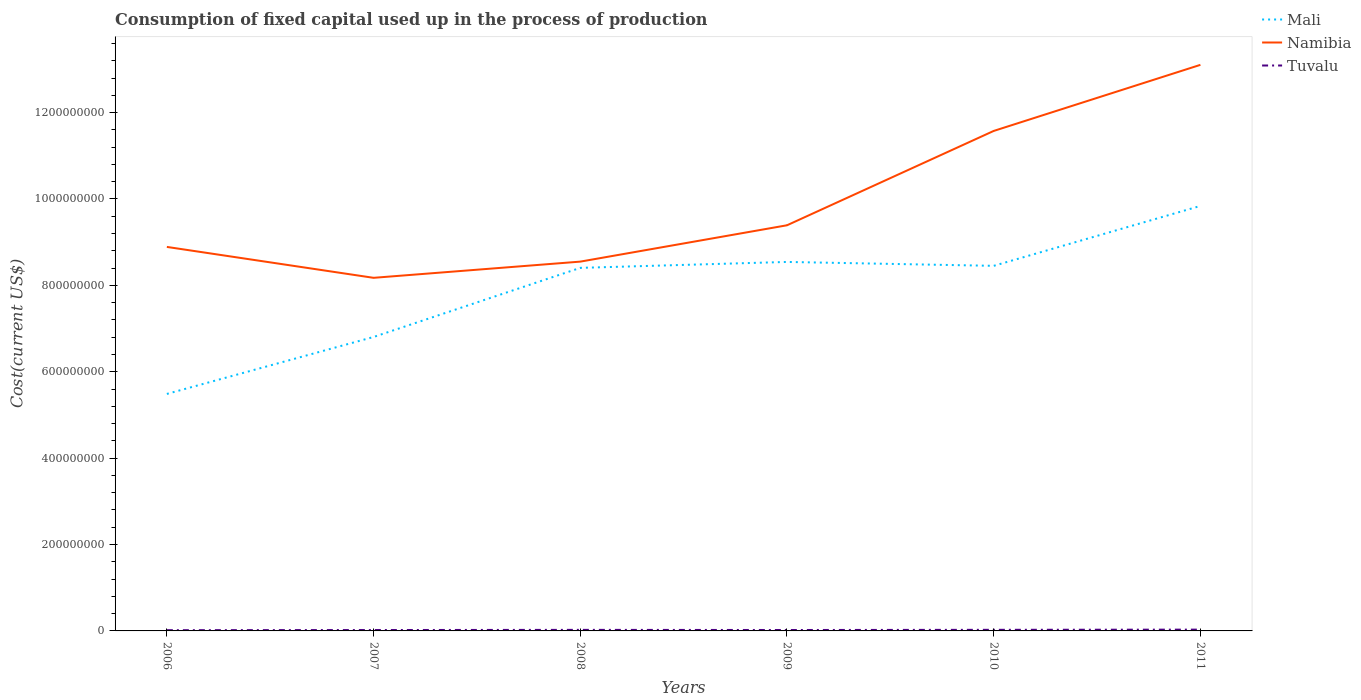Does the line corresponding to Namibia intersect with the line corresponding to Tuvalu?
Offer a very short reply. No. Across all years, what is the maximum amount consumed in the process of production in Tuvalu?
Keep it short and to the point. 1.71e+06. In which year was the amount consumed in the process of production in Mali maximum?
Offer a very short reply. 2006. What is the total amount consumed in the process of production in Namibia in the graph?
Give a very brief answer. -5.01e+07. What is the difference between the highest and the second highest amount consumed in the process of production in Namibia?
Offer a terse response. 4.93e+08. How many years are there in the graph?
Ensure brevity in your answer.  6. What is the difference between two consecutive major ticks on the Y-axis?
Your response must be concise. 2.00e+08. Are the values on the major ticks of Y-axis written in scientific E-notation?
Offer a terse response. No. Does the graph contain grids?
Make the answer very short. No. How are the legend labels stacked?
Offer a terse response. Vertical. What is the title of the graph?
Ensure brevity in your answer.  Consumption of fixed capital used up in the process of production. Does "Lao PDR" appear as one of the legend labels in the graph?
Give a very brief answer. No. What is the label or title of the Y-axis?
Your response must be concise. Cost(current US$). What is the Cost(current US$) in Mali in 2006?
Your answer should be compact. 5.49e+08. What is the Cost(current US$) in Namibia in 2006?
Offer a very short reply. 8.89e+08. What is the Cost(current US$) in Tuvalu in 2006?
Provide a succinct answer. 1.71e+06. What is the Cost(current US$) of Mali in 2007?
Your response must be concise. 6.81e+08. What is the Cost(current US$) of Namibia in 2007?
Give a very brief answer. 8.17e+08. What is the Cost(current US$) of Tuvalu in 2007?
Offer a terse response. 2.07e+06. What is the Cost(current US$) in Mali in 2008?
Your answer should be compact. 8.41e+08. What is the Cost(current US$) of Namibia in 2008?
Provide a succinct answer. 8.55e+08. What is the Cost(current US$) of Tuvalu in 2008?
Give a very brief answer. 2.43e+06. What is the Cost(current US$) in Mali in 2009?
Provide a succinct answer. 8.54e+08. What is the Cost(current US$) in Namibia in 2009?
Make the answer very short. 9.39e+08. What is the Cost(current US$) in Tuvalu in 2009?
Your answer should be very brief. 2.11e+06. What is the Cost(current US$) in Mali in 2010?
Give a very brief answer. 8.45e+08. What is the Cost(current US$) of Namibia in 2010?
Your answer should be very brief. 1.16e+09. What is the Cost(current US$) in Tuvalu in 2010?
Keep it short and to the point. 2.54e+06. What is the Cost(current US$) of Mali in 2011?
Keep it short and to the point. 9.84e+08. What is the Cost(current US$) in Namibia in 2011?
Ensure brevity in your answer.  1.31e+09. What is the Cost(current US$) in Tuvalu in 2011?
Provide a succinct answer. 3.00e+06. Across all years, what is the maximum Cost(current US$) of Mali?
Ensure brevity in your answer.  9.84e+08. Across all years, what is the maximum Cost(current US$) of Namibia?
Give a very brief answer. 1.31e+09. Across all years, what is the maximum Cost(current US$) of Tuvalu?
Provide a succinct answer. 3.00e+06. Across all years, what is the minimum Cost(current US$) in Mali?
Your answer should be compact. 5.49e+08. Across all years, what is the minimum Cost(current US$) of Namibia?
Provide a short and direct response. 8.17e+08. Across all years, what is the minimum Cost(current US$) in Tuvalu?
Ensure brevity in your answer.  1.71e+06. What is the total Cost(current US$) of Mali in the graph?
Keep it short and to the point. 4.75e+09. What is the total Cost(current US$) of Namibia in the graph?
Your answer should be compact. 5.97e+09. What is the total Cost(current US$) in Tuvalu in the graph?
Ensure brevity in your answer.  1.39e+07. What is the difference between the Cost(current US$) of Mali in 2006 and that in 2007?
Keep it short and to the point. -1.32e+08. What is the difference between the Cost(current US$) of Namibia in 2006 and that in 2007?
Provide a short and direct response. 7.16e+07. What is the difference between the Cost(current US$) of Tuvalu in 2006 and that in 2007?
Make the answer very short. -3.62e+05. What is the difference between the Cost(current US$) of Mali in 2006 and that in 2008?
Your answer should be very brief. -2.92e+08. What is the difference between the Cost(current US$) in Namibia in 2006 and that in 2008?
Your answer should be very brief. 3.40e+07. What is the difference between the Cost(current US$) of Tuvalu in 2006 and that in 2008?
Your response must be concise. -7.25e+05. What is the difference between the Cost(current US$) of Mali in 2006 and that in 2009?
Offer a very short reply. -3.06e+08. What is the difference between the Cost(current US$) of Namibia in 2006 and that in 2009?
Give a very brief answer. -5.01e+07. What is the difference between the Cost(current US$) in Tuvalu in 2006 and that in 2009?
Keep it short and to the point. -3.97e+05. What is the difference between the Cost(current US$) in Mali in 2006 and that in 2010?
Provide a short and direct response. -2.97e+08. What is the difference between the Cost(current US$) of Namibia in 2006 and that in 2010?
Offer a terse response. -2.68e+08. What is the difference between the Cost(current US$) of Tuvalu in 2006 and that in 2010?
Keep it short and to the point. -8.27e+05. What is the difference between the Cost(current US$) in Mali in 2006 and that in 2011?
Offer a very short reply. -4.35e+08. What is the difference between the Cost(current US$) of Namibia in 2006 and that in 2011?
Give a very brief answer. -4.22e+08. What is the difference between the Cost(current US$) in Tuvalu in 2006 and that in 2011?
Provide a succinct answer. -1.29e+06. What is the difference between the Cost(current US$) in Mali in 2007 and that in 2008?
Provide a succinct answer. -1.60e+08. What is the difference between the Cost(current US$) of Namibia in 2007 and that in 2008?
Your answer should be compact. -3.75e+07. What is the difference between the Cost(current US$) in Tuvalu in 2007 and that in 2008?
Provide a short and direct response. -3.63e+05. What is the difference between the Cost(current US$) in Mali in 2007 and that in 2009?
Ensure brevity in your answer.  -1.74e+08. What is the difference between the Cost(current US$) of Namibia in 2007 and that in 2009?
Keep it short and to the point. -1.22e+08. What is the difference between the Cost(current US$) in Tuvalu in 2007 and that in 2009?
Make the answer very short. -3.53e+04. What is the difference between the Cost(current US$) in Mali in 2007 and that in 2010?
Your answer should be very brief. -1.65e+08. What is the difference between the Cost(current US$) of Namibia in 2007 and that in 2010?
Provide a short and direct response. -3.40e+08. What is the difference between the Cost(current US$) in Tuvalu in 2007 and that in 2010?
Ensure brevity in your answer.  -4.65e+05. What is the difference between the Cost(current US$) in Mali in 2007 and that in 2011?
Ensure brevity in your answer.  -3.03e+08. What is the difference between the Cost(current US$) of Namibia in 2007 and that in 2011?
Your answer should be compact. -4.93e+08. What is the difference between the Cost(current US$) of Tuvalu in 2007 and that in 2011?
Keep it short and to the point. -9.27e+05. What is the difference between the Cost(current US$) of Mali in 2008 and that in 2009?
Keep it short and to the point. -1.37e+07. What is the difference between the Cost(current US$) in Namibia in 2008 and that in 2009?
Give a very brief answer. -8.41e+07. What is the difference between the Cost(current US$) of Tuvalu in 2008 and that in 2009?
Your answer should be compact. 3.27e+05. What is the difference between the Cost(current US$) in Mali in 2008 and that in 2010?
Provide a short and direct response. -4.70e+06. What is the difference between the Cost(current US$) in Namibia in 2008 and that in 2010?
Give a very brief answer. -3.03e+08. What is the difference between the Cost(current US$) of Tuvalu in 2008 and that in 2010?
Provide a short and direct response. -1.02e+05. What is the difference between the Cost(current US$) of Mali in 2008 and that in 2011?
Make the answer very short. -1.43e+08. What is the difference between the Cost(current US$) in Namibia in 2008 and that in 2011?
Ensure brevity in your answer.  -4.56e+08. What is the difference between the Cost(current US$) in Tuvalu in 2008 and that in 2011?
Your answer should be compact. -5.65e+05. What is the difference between the Cost(current US$) in Mali in 2009 and that in 2010?
Offer a terse response. 9.03e+06. What is the difference between the Cost(current US$) of Namibia in 2009 and that in 2010?
Offer a terse response. -2.18e+08. What is the difference between the Cost(current US$) of Tuvalu in 2009 and that in 2010?
Provide a succinct answer. -4.30e+05. What is the difference between the Cost(current US$) of Mali in 2009 and that in 2011?
Give a very brief answer. -1.30e+08. What is the difference between the Cost(current US$) of Namibia in 2009 and that in 2011?
Ensure brevity in your answer.  -3.71e+08. What is the difference between the Cost(current US$) of Tuvalu in 2009 and that in 2011?
Your response must be concise. -8.92e+05. What is the difference between the Cost(current US$) in Mali in 2010 and that in 2011?
Keep it short and to the point. -1.39e+08. What is the difference between the Cost(current US$) in Namibia in 2010 and that in 2011?
Your answer should be compact. -1.53e+08. What is the difference between the Cost(current US$) in Tuvalu in 2010 and that in 2011?
Your response must be concise. -4.62e+05. What is the difference between the Cost(current US$) in Mali in 2006 and the Cost(current US$) in Namibia in 2007?
Your response must be concise. -2.69e+08. What is the difference between the Cost(current US$) in Mali in 2006 and the Cost(current US$) in Tuvalu in 2007?
Make the answer very short. 5.47e+08. What is the difference between the Cost(current US$) in Namibia in 2006 and the Cost(current US$) in Tuvalu in 2007?
Give a very brief answer. 8.87e+08. What is the difference between the Cost(current US$) of Mali in 2006 and the Cost(current US$) of Namibia in 2008?
Offer a very short reply. -3.06e+08. What is the difference between the Cost(current US$) of Mali in 2006 and the Cost(current US$) of Tuvalu in 2008?
Ensure brevity in your answer.  5.46e+08. What is the difference between the Cost(current US$) in Namibia in 2006 and the Cost(current US$) in Tuvalu in 2008?
Make the answer very short. 8.87e+08. What is the difference between the Cost(current US$) of Mali in 2006 and the Cost(current US$) of Namibia in 2009?
Give a very brief answer. -3.90e+08. What is the difference between the Cost(current US$) of Mali in 2006 and the Cost(current US$) of Tuvalu in 2009?
Make the answer very short. 5.47e+08. What is the difference between the Cost(current US$) in Namibia in 2006 and the Cost(current US$) in Tuvalu in 2009?
Your answer should be compact. 8.87e+08. What is the difference between the Cost(current US$) in Mali in 2006 and the Cost(current US$) in Namibia in 2010?
Provide a succinct answer. -6.09e+08. What is the difference between the Cost(current US$) of Mali in 2006 and the Cost(current US$) of Tuvalu in 2010?
Give a very brief answer. 5.46e+08. What is the difference between the Cost(current US$) in Namibia in 2006 and the Cost(current US$) in Tuvalu in 2010?
Provide a succinct answer. 8.86e+08. What is the difference between the Cost(current US$) in Mali in 2006 and the Cost(current US$) in Namibia in 2011?
Your answer should be compact. -7.62e+08. What is the difference between the Cost(current US$) in Mali in 2006 and the Cost(current US$) in Tuvalu in 2011?
Your answer should be very brief. 5.46e+08. What is the difference between the Cost(current US$) in Namibia in 2006 and the Cost(current US$) in Tuvalu in 2011?
Provide a short and direct response. 8.86e+08. What is the difference between the Cost(current US$) in Mali in 2007 and the Cost(current US$) in Namibia in 2008?
Ensure brevity in your answer.  -1.74e+08. What is the difference between the Cost(current US$) of Mali in 2007 and the Cost(current US$) of Tuvalu in 2008?
Keep it short and to the point. 6.78e+08. What is the difference between the Cost(current US$) in Namibia in 2007 and the Cost(current US$) in Tuvalu in 2008?
Provide a succinct answer. 8.15e+08. What is the difference between the Cost(current US$) of Mali in 2007 and the Cost(current US$) of Namibia in 2009?
Make the answer very short. -2.59e+08. What is the difference between the Cost(current US$) of Mali in 2007 and the Cost(current US$) of Tuvalu in 2009?
Your answer should be compact. 6.78e+08. What is the difference between the Cost(current US$) in Namibia in 2007 and the Cost(current US$) in Tuvalu in 2009?
Offer a very short reply. 8.15e+08. What is the difference between the Cost(current US$) in Mali in 2007 and the Cost(current US$) in Namibia in 2010?
Give a very brief answer. -4.77e+08. What is the difference between the Cost(current US$) of Mali in 2007 and the Cost(current US$) of Tuvalu in 2010?
Your answer should be very brief. 6.78e+08. What is the difference between the Cost(current US$) in Namibia in 2007 and the Cost(current US$) in Tuvalu in 2010?
Provide a succinct answer. 8.15e+08. What is the difference between the Cost(current US$) of Mali in 2007 and the Cost(current US$) of Namibia in 2011?
Your response must be concise. -6.30e+08. What is the difference between the Cost(current US$) in Mali in 2007 and the Cost(current US$) in Tuvalu in 2011?
Ensure brevity in your answer.  6.78e+08. What is the difference between the Cost(current US$) in Namibia in 2007 and the Cost(current US$) in Tuvalu in 2011?
Offer a very short reply. 8.14e+08. What is the difference between the Cost(current US$) in Mali in 2008 and the Cost(current US$) in Namibia in 2009?
Ensure brevity in your answer.  -9.86e+07. What is the difference between the Cost(current US$) in Mali in 2008 and the Cost(current US$) in Tuvalu in 2009?
Your answer should be very brief. 8.38e+08. What is the difference between the Cost(current US$) in Namibia in 2008 and the Cost(current US$) in Tuvalu in 2009?
Give a very brief answer. 8.53e+08. What is the difference between the Cost(current US$) in Mali in 2008 and the Cost(current US$) in Namibia in 2010?
Offer a very short reply. -3.17e+08. What is the difference between the Cost(current US$) of Mali in 2008 and the Cost(current US$) of Tuvalu in 2010?
Your response must be concise. 8.38e+08. What is the difference between the Cost(current US$) of Namibia in 2008 and the Cost(current US$) of Tuvalu in 2010?
Ensure brevity in your answer.  8.52e+08. What is the difference between the Cost(current US$) in Mali in 2008 and the Cost(current US$) in Namibia in 2011?
Offer a very short reply. -4.70e+08. What is the difference between the Cost(current US$) in Mali in 2008 and the Cost(current US$) in Tuvalu in 2011?
Your response must be concise. 8.38e+08. What is the difference between the Cost(current US$) of Namibia in 2008 and the Cost(current US$) of Tuvalu in 2011?
Ensure brevity in your answer.  8.52e+08. What is the difference between the Cost(current US$) in Mali in 2009 and the Cost(current US$) in Namibia in 2010?
Offer a very short reply. -3.03e+08. What is the difference between the Cost(current US$) of Mali in 2009 and the Cost(current US$) of Tuvalu in 2010?
Offer a very short reply. 8.52e+08. What is the difference between the Cost(current US$) of Namibia in 2009 and the Cost(current US$) of Tuvalu in 2010?
Give a very brief answer. 9.37e+08. What is the difference between the Cost(current US$) in Mali in 2009 and the Cost(current US$) in Namibia in 2011?
Make the answer very short. -4.56e+08. What is the difference between the Cost(current US$) in Mali in 2009 and the Cost(current US$) in Tuvalu in 2011?
Your answer should be very brief. 8.51e+08. What is the difference between the Cost(current US$) of Namibia in 2009 and the Cost(current US$) of Tuvalu in 2011?
Ensure brevity in your answer.  9.36e+08. What is the difference between the Cost(current US$) of Mali in 2010 and the Cost(current US$) of Namibia in 2011?
Make the answer very short. -4.65e+08. What is the difference between the Cost(current US$) in Mali in 2010 and the Cost(current US$) in Tuvalu in 2011?
Offer a terse response. 8.42e+08. What is the difference between the Cost(current US$) in Namibia in 2010 and the Cost(current US$) in Tuvalu in 2011?
Make the answer very short. 1.15e+09. What is the average Cost(current US$) of Mali per year?
Your answer should be compact. 7.92e+08. What is the average Cost(current US$) of Namibia per year?
Keep it short and to the point. 9.95e+08. What is the average Cost(current US$) of Tuvalu per year?
Make the answer very short. 2.31e+06. In the year 2006, what is the difference between the Cost(current US$) in Mali and Cost(current US$) in Namibia?
Make the answer very short. -3.40e+08. In the year 2006, what is the difference between the Cost(current US$) of Mali and Cost(current US$) of Tuvalu?
Your answer should be compact. 5.47e+08. In the year 2006, what is the difference between the Cost(current US$) in Namibia and Cost(current US$) in Tuvalu?
Your answer should be compact. 8.87e+08. In the year 2007, what is the difference between the Cost(current US$) of Mali and Cost(current US$) of Namibia?
Offer a terse response. -1.37e+08. In the year 2007, what is the difference between the Cost(current US$) in Mali and Cost(current US$) in Tuvalu?
Offer a terse response. 6.78e+08. In the year 2007, what is the difference between the Cost(current US$) in Namibia and Cost(current US$) in Tuvalu?
Your answer should be very brief. 8.15e+08. In the year 2008, what is the difference between the Cost(current US$) of Mali and Cost(current US$) of Namibia?
Provide a succinct answer. -1.45e+07. In the year 2008, what is the difference between the Cost(current US$) of Mali and Cost(current US$) of Tuvalu?
Your answer should be very brief. 8.38e+08. In the year 2008, what is the difference between the Cost(current US$) of Namibia and Cost(current US$) of Tuvalu?
Your response must be concise. 8.53e+08. In the year 2009, what is the difference between the Cost(current US$) of Mali and Cost(current US$) of Namibia?
Your answer should be compact. -8.49e+07. In the year 2009, what is the difference between the Cost(current US$) in Mali and Cost(current US$) in Tuvalu?
Offer a very short reply. 8.52e+08. In the year 2009, what is the difference between the Cost(current US$) of Namibia and Cost(current US$) of Tuvalu?
Your response must be concise. 9.37e+08. In the year 2010, what is the difference between the Cost(current US$) in Mali and Cost(current US$) in Namibia?
Give a very brief answer. -3.12e+08. In the year 2010, what is the difference between the Cost(current US$) in Mali and Cost(current US$) in Tuvalu?
Ensure brevity in your answer.  8.43e+08. In the year 2010, what is the difference between the Cost(current US$) in Namibia and Cost(current US$) in Tuvalu?
Ensure brevity in your answer.  1.15e+09. In the year 2011, what is the difference between the Cost(current US$) in Mali and Cost(current US$) in Namibia?
Provide a short and direct response. -3.27e+08. In the year 2011, what is the difference between the Cost(current US$) in Mali and Cost(current US$) in Tuvalu?
Ensure brevity in your answer.  9.81e+08. In the year 2011, what is the difference between the Cost(current US$) in Namibia and Cost(current US$) in Tuvalu?
Provide a succinct answer. 1.31e+09. What is the ratio of the Cost(current US$) in Mali in 2006 to that in 2007?
Give a very brief answer. 0.81. What is the ratio of the Cost(current US$) of Namibia in 2006 to that in 2007?
Your answer should be compact. 1.09. What is the ratio of the Cost(current US$) in Tuvalu in 2006 to that in 2007?
Your answer should be very brief. 0.83. What is the ratio of the Cost(current US$) in Mali in 2006 to that in 2008?
Keep it short and to the point. 0.65. What is the ratio of the Cost(current US$) of Namibia in 2006 to that in 2008?
Your answer should be compact. 1.04. What is the ratio of the Cost(current US$) of Tuvalu in 2006 to that in 2008?
Offer a very short reply. 0.7. What is the ratio of the Cost(current US$) in Mali in 2006 to that in 2009?
Your answer should be compact. 0.64. What is the ratio of the Cost(current US$) of Namibia in 2006 to that in 2009?
Give a very brief answer. 0.95. What is the ratio of the Cost(current US$) in Tuvalu in 2006 to that in 2009?
Keep it short and to the point. 0.81. What is the ratio of the Cost(current US$) of Mali in 2006 to that in 2010?
Give a very brief answer. 0.65. What is the ratio of the Cost(current US$) in Namibia in 2006 to that in 2010?
Provide a short and direct response. 0.77. What is the ratio of the Cost(current US$) of Tuvalu in 2006 to that in 2010?
Your answer should be compact. 0.67. What is the ratio of the Cost(current US$) of Mali in 2006 to that in 2011?
Provide a succinct answer. 0.56. What is the ratio of the Cost(current US$) of Namibia in 2006 to that in 2011?
Give a very brief answer. 0.68. What is the ratio of the Cost(current US$) in Tuvalu in 2006 to that in 2011?
Offer a terse response. 0.57. What is the ratio of the Cost(current US$) of Mali in 2007 to that in 2008?
Offer a very short reply. 0.81. What is the ratio of the Cost(current US$) in Namibia in 2007 to that in 2008?
Give a very brief answer. 0.96. What is the ratio of the Cost(current US$) of Tuvalu in 2007 to that in 2008?
Your answer should be compact. 0.85. What is the ratio of the Cost(current US$) of Mali in 2007 to that in 2009?
Make the answer very short. 0.8. What is the ratio of the Cost(current US$) of Namibia in 2007 to that in 2009?
Ensure brevity in your answer.  0.87. What is the ratio of the Cost(current US$) of Tuvalu in 2007 to that in 2009?
Your response must be concise. 0.98. What is the ratio of the Cost(current US$) of Mali in 2007 to that in 2010?
Ensure brevity in your answer.  0.81. What is the ratio of the Cost(current US$) of Namibia in 2007 to that in 2010?
Provide a succinct answer. 0.71. What is the ratio of the Cost(current US$) of Tuvalu in 2007 to that in 2010?
Offer a terse response. 0.82. What is the ratio of the Cost(current US$) of Mali in 2007 to that in 2011?
Provide a short and direct response. 0.69. What is the ratio of the Cost(current US$) in Namibia in 2007 to that in 2011?
Make the answer very short. 0.62. What is the ratio of the Cost(current US$) in Tuvalu in 2007 to that in 2011?
Ensure brevity in your answer.  0.69. What is the ratio of the Cost(current US$) of Mali in 2008 to that in 2009?
Provide a succinct answer. 0.98. What is the ratio of the Cost(current US$) in Namibia in 2008 to that in 2009?
Your response must be concise. 0.91. What is the ratio of the Cost(current US$) of Tuvalu in 2008 to that in 2009?
Provide a succinct answer. 1.16. What is the ratio of the Cost(current US$) of Namibia in 2008 to that in 2010?
Keep it short and to the point. 0.74. What is the ratio of the Cost(current US$) in Tuvalu in 2008 to that in 2010?
Offer a very short reply. 0.96. What is the ratio of the Cost(current US$) of Mali in 2008 to that in 2011?
Keep it short and to the point. 0.85. What is the ratio of the Cost(current US$) in Namibia in 2008 to that in 2011?
Give a very brief answer. 0.65. What is the ratio of the Cost(current US$) in Tuvalu in 2008 to that in 2011?
Give a very brief answer. 0.81. What is the ratio of the Cost(current US$) of Mali in 2009 to that in 2010?
Your answer should be compact. 1.01. What is the ratio of the Cost(current US$) of Namibia in 2009 to that in 2010?
Your answer should be very brief. 0.81. What is the ratio of the Cost(current US$) in Tuvalu in 2009 to that in 2010?
Offer a terse response. 0.83. What is the ratio of the Cost(current US$) in Mali in 2009 to that in 2011?
Offer a terse response. 0.87. What is the ratio of the Cost(current US$) in Namibia in 2009 to that in 2011?
Provide a succinct answer. 0.72. What is the ratio of the Cost(current US$) in Tuvalu in 2009 to that in 2011?
Give a very brief answer. 0.7. What is the ratio of the Cost(current US$) of Mali in 2010 to that in 2011?
Your response must be concise. 0.86. What is the ratio of the Cost(current US$) of Namibia in 2010 to that in 2011?
Make the answer very short. 0.88. What is the ratio of the Cost(current US$) in Tuvalu in 2010 to that in 2011?
Your response must be concise. 0.85. What is the difference between the highest and the second highest Cost(current US$) in Mali?
Offer a terse response. 1.30e+08. What is the difference between the highest and the second highest Cost(current US$) in Namibia?
Ensure brevity in your answer.  1.53e+08. What is the difference between the highest and the second highest Cost(current US$) of Tuvalu?
Offer a very short reply. 4.62e+05. What is the difference between the highest and the lowest Cost(current US$) in Mali?
Make the answer very short. 4.35e+08. What is the difference between the highest and the lowest Cost(current US$) of Namibia?
Ensure brevity in your answer.  4.93e+08. What is the difference between the highest and the lowest Cost(current US$) in Tuvalu?
Your response must be concise. 1.29e+06. 